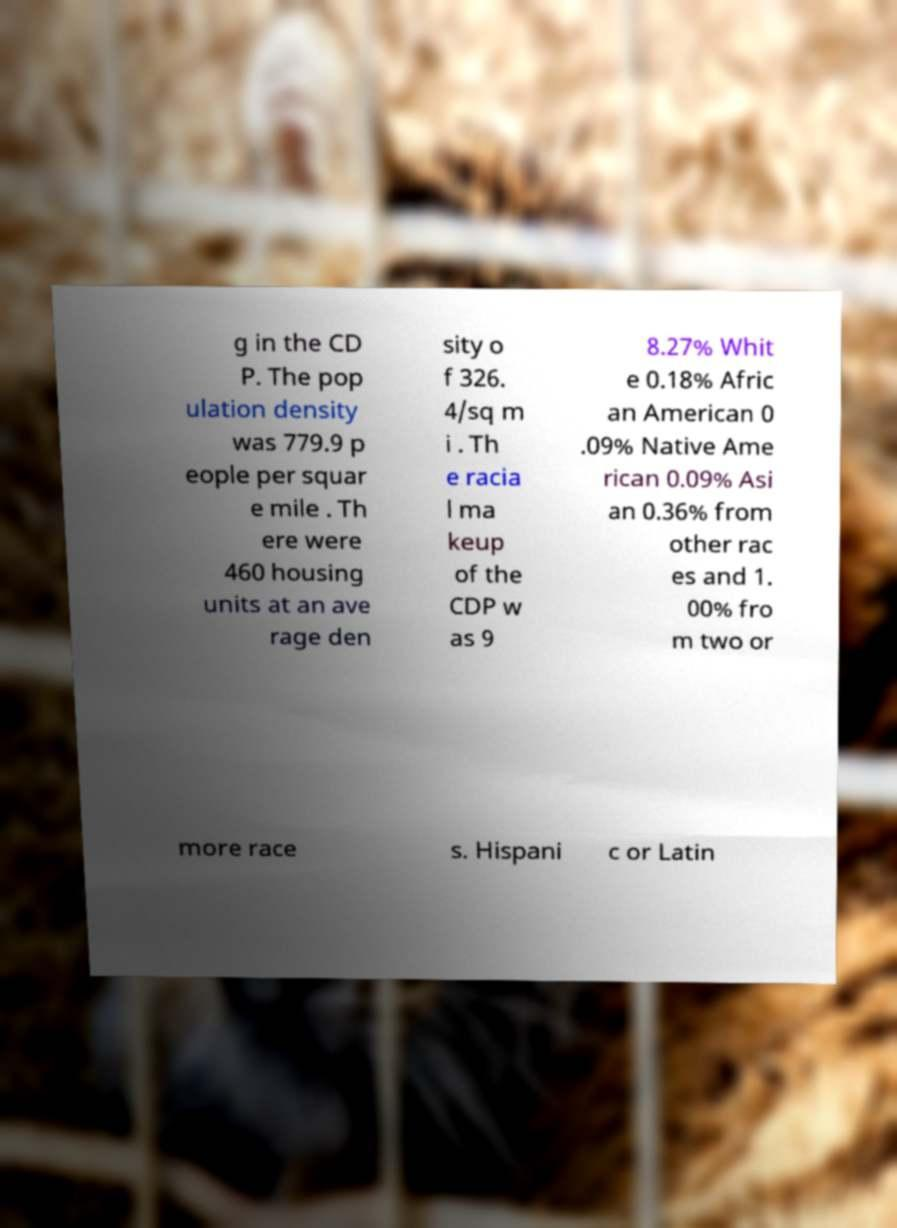Please read and relay the text visible in this image. What does it say? g in the CD P. The pop ulation density was 779.9 p eople per squar e mile . Th ere were 460 housing units at an ave rage den sity o f 326. 4/sq m i . Th e racia l ma keup of the CDP w as 9 8.27% Whit e 0.18% Afric an American 0 .09% Native Ame rican 0.09% Asi an 0.36% from other rac es and 1. 00% fro m two or more race s. Hispani c or Latin 